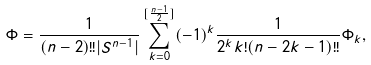Convert formula to latex. <formula><loc_0><loc_0><loc_500><loc_500>\Phi = \frac { 1 } { ( n - 2 ) ! ! | S ^ { n - 1 } | } \sum _ { k = 0 } ^ { [ \frac { n - 1 } 2 ] } ( - 1 ) ^ { k } \frac { 1 } { 2 ^ { k } k ! ( n - 2 k - 1 ) ! ! } \Phi _ { k } ,</formula> 